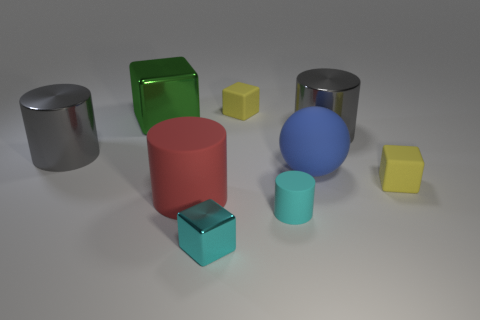There is a small object that is the same color as the tiny rubber cylinder; what is its shape?
Provide a short and direct response. Cube. What is the shape of the cyan thing that is made of the same material as the large blue thing?
Offer a very short reply. Cylinder. There is a gray cylinder to the left of the blue object on the right side of the cyan cylinder; what size is it?
Provide a short and direct response. Large. How many things are either big red objects left of the small cylinder or tiny blocks in front of the big blue matte thing?
Offer a terse response. 3. Are there fewer small blocks than small cyan shiny objects?
Provide a succinct answer. No. How many objects are rubber cylinders or small balls?
Make the answer very short. 2. Do the red thing and the blue matte object have the same shape?
Offer a very short reply. No. Are there any other things that are the same material as the large blue ball?
Keep it short and to the point. Yes. Does the gray thing that is to the left of the green shiny thing have the same size as the yellow rubber object to the left of the tiny cyan rubber cylinder?
Offer a terse response. No. The cylinder that is both to the left of the cyan block and to the right of the green object is made of what material?
Your response must be concise. Rubber. 